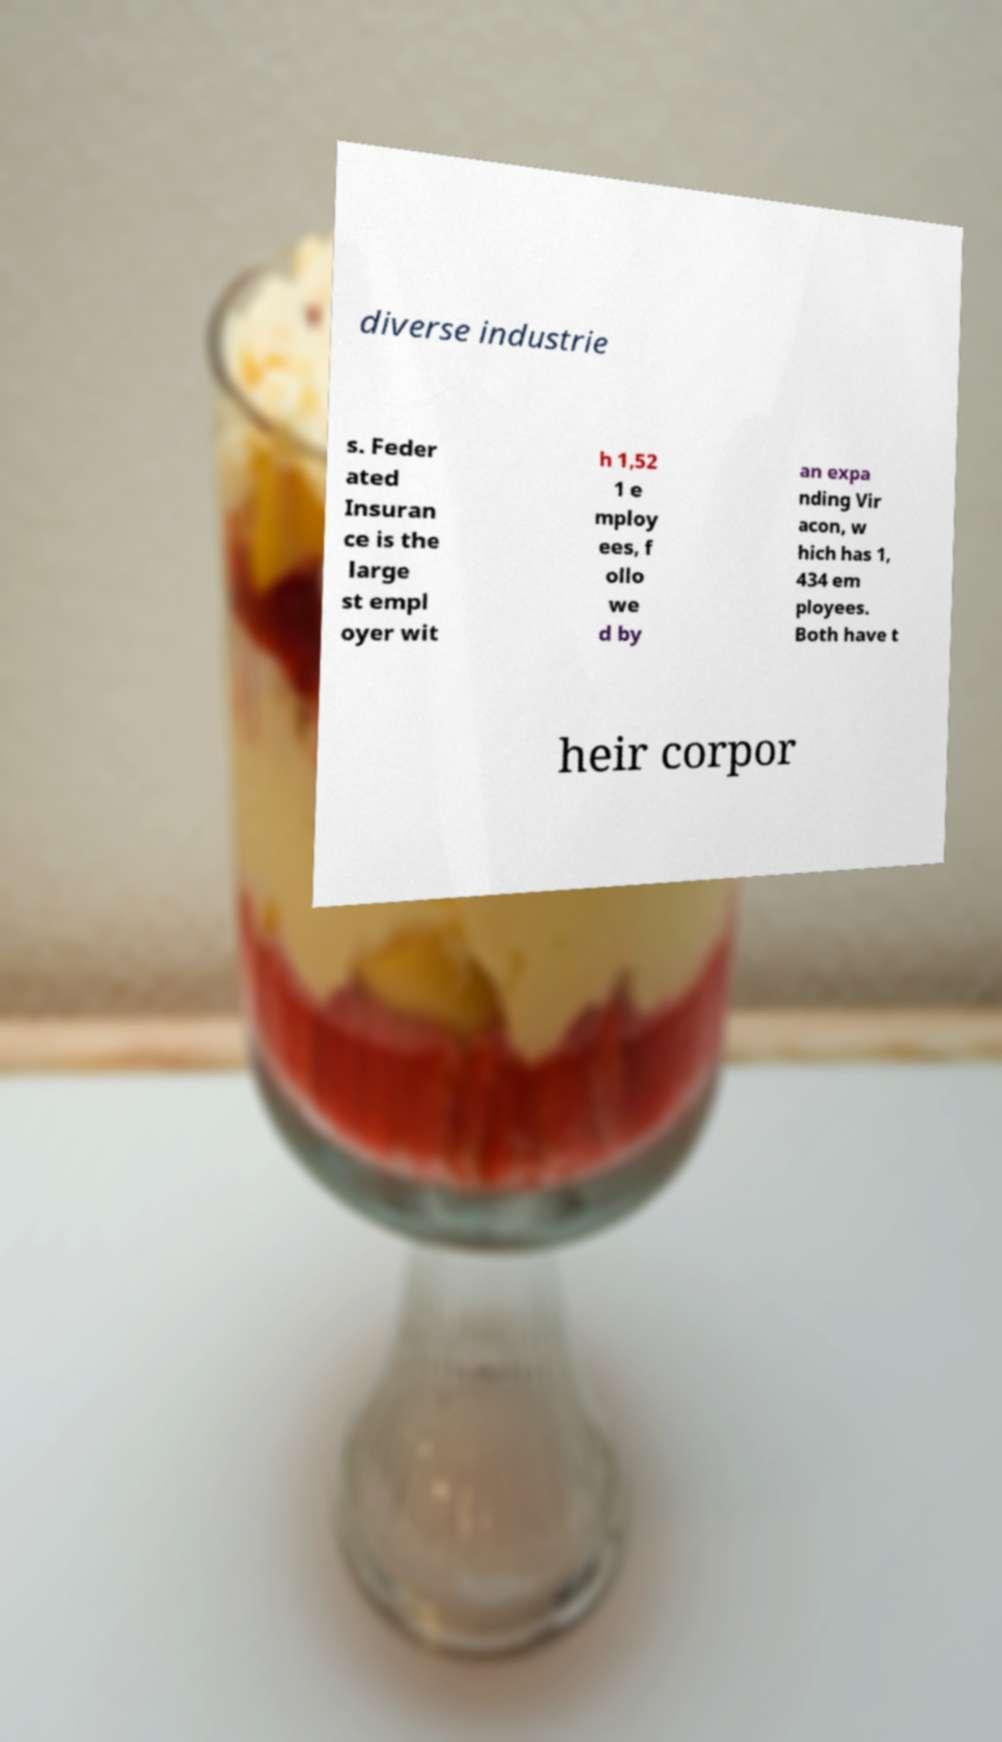Could you assist in decoding the text presented in this image and type it out clearly? diverse industrie s. Feder ated Insuran ce is the large st empl oyer wit h 1,52 1 e mploy ees, f ollo we d by an expa nding Vir acon, w hich has 1, 434 em ployees. Both have t heir corpor 